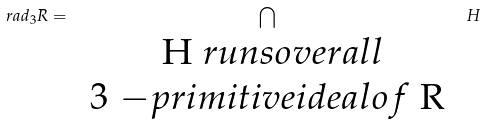<formula> <loc_0><loc_0><loc_500><loc_500>r a d _ { 3 } R = \bigcap _ { \begin{array} { c } $ H $ r u n s o v e r a l l \\ $ 3 $ - p r i m i t i v e i d e a l o f $ R $ \end{array} } H</formula> 